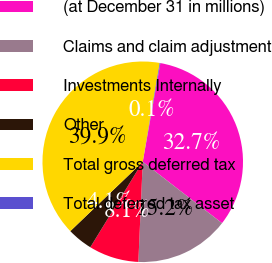Convert chart. <chart><loc_0><loc_0><loc_500><loc_500><pie_chart><fcel>(at December 31 in millions)<fcel>Claims and claim adjustment<fcel>Investments Internally<fcel>Other<fcel>Total gross deferred tax<fcel>Total deferred tax asset<nl><fcel>32.67%<fcel>15.21%<fcel>8.06%<fcel>4.09%<fcel>39.86%<fcel>0.11%<nl></chart> 